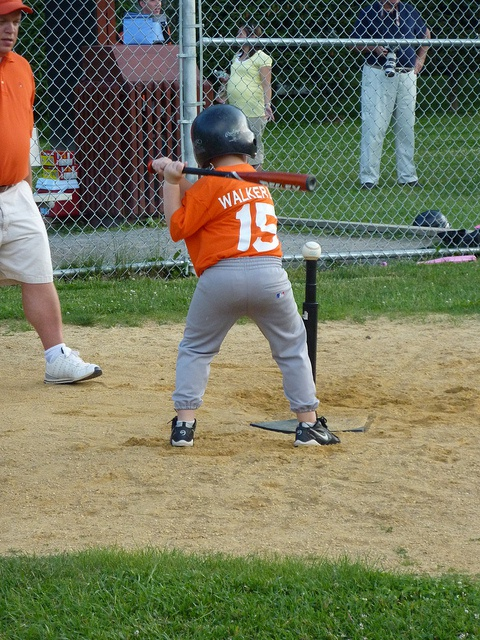Describe the objects in this image and their specific colors. I can see people in brown, darkgray, gray, red, and lightgray tones, people in brown, lightgray, red, darkgray, and gray tones, people in brown, darkgray, gray, black, and lightblue tones, people in brown, darkgray, beige, and gray tones, and baseball bat in brown, maroon, black, gray, and red tones in this image. 